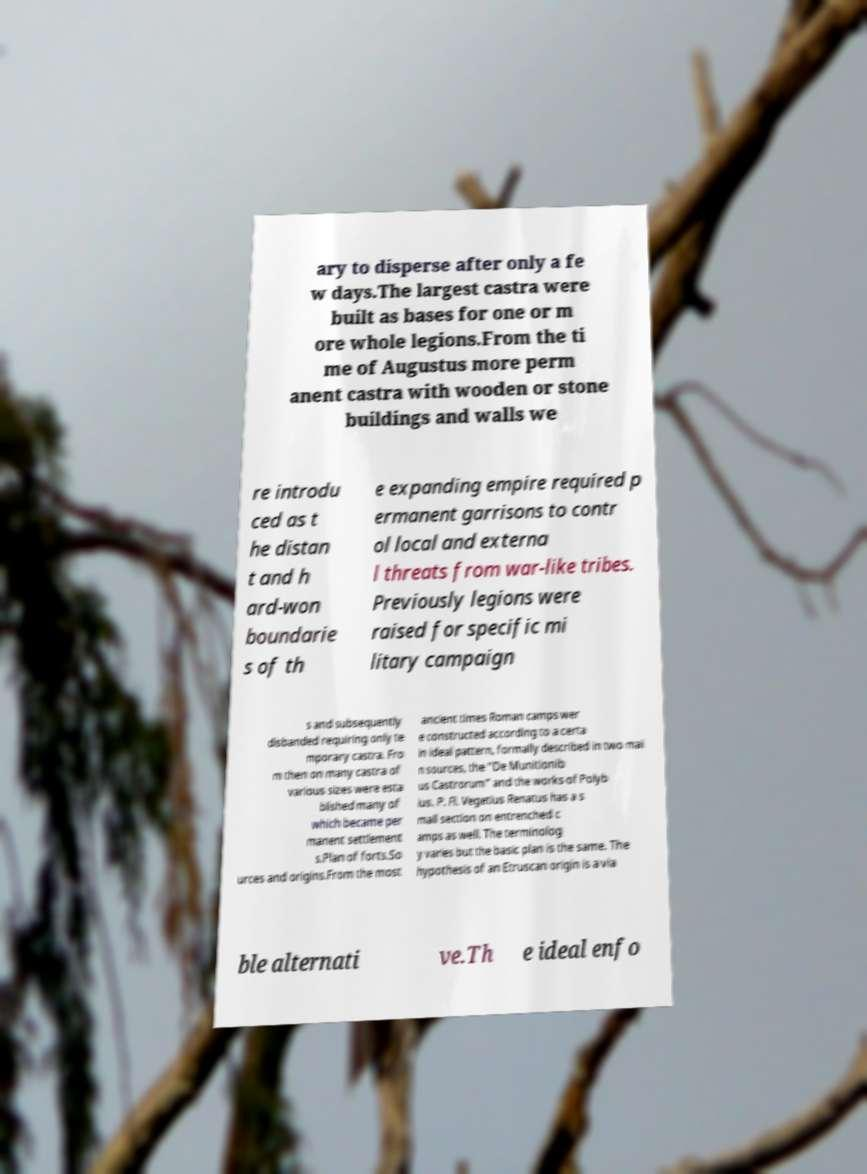Could you extract and type out the text from this image? ary to disperse after only a fe w days.The largest castra were built as bases for one or m ore whole legions.From the ti me of Augustus more perm anent castra with wooden or stone buildings and walls we re introdu ced as t he distan t and h ard-won boundarie s of th e expanding empire required p ermanent garrisons to contr ol local and externa l threats from war-like tribes. Previously legions were raised for specific mi litary campaign s and subsequently disbanded requiring only te mporary castra. Fro m then on many castra of various sizes were esta blished many of which became per manent settlement s.Plan of forts.So urces and origins.From the most ancient times Roman camps wer e constructed according to a certa in ideal pattern, formally described in two mai n sources, the "De Munitionib us Castrorum" and the works of Polyb ius. P. Fl. Vegetius Renatus has a s mall section on entrenched c amps as well. The terminolog y varies but the basic plan is the same. The hypothesis of an Etruscan origin is a via ble alternati ve.Th e ideal enfo 